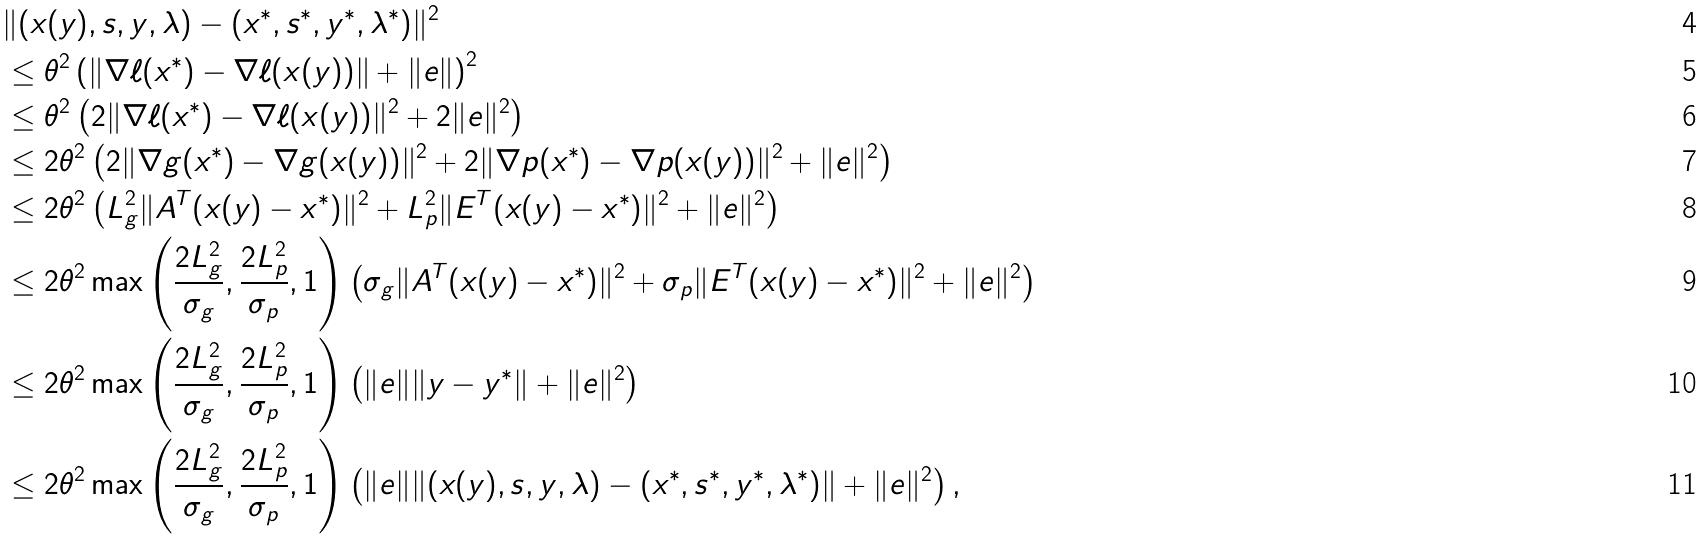Convert formula to latex. <formula><loc_0><loc_0><loc_500><loc_500>& \| ( x ( y ) , s , y , \lambda ) - ( x ^ { * } , s ^ { * } , y ^ { * } , \lambda ^ { * } ) \| ^ { 2 } \\ & \leq \theta ^ { 2 } \left ( \| \nabla \ell ( x ^ { * } ) - \nabla \ell ( x ( y ) ) \| + \| e \| \right ) ^ { 2 } \\ & \leq \theta ^ { 2 } \left ( 2 \| \nabla \ell ( x ^ { * } ) - \nabla \ell ( x ( y ) ) \| ^ { 2 } + 2 \| e \| ^ { 2 } \right ) \\ & \leq 2 \theta ^ { 2 } \left ( 2 \| \nabla g ( x ^ { * } ) - \nabla g ( x ( y ) ) \| ^ { 2 } + 2 \| \nabla p ( x ^ { * } ) - \nabla p ( x ( y ) ) \| ^ { 2 } + \| e \| ^ { 2 } \right ) \\ & \leq 2 \theta ^ { 2 } \left ( L ^ { 2 } _ { g } \| A ^ { T } ( x ( y ) - x ^ { * } ) \| ^ { 2 } + L ^ { 2 } _ { p } \| E ^ { T } ( x ( y ) - x ^ { * } ) \| ^ { 2 } + \| e \| ^ { 2 } \right ) \\ & \leq 2 \theta ^ { 2 } \max \left ( \frac { 2 L ^ { 2 } _ { g } } { \sigma _ { g } } , \frac { 2 L ^ { 2 } _ { p } } { \sigma _ { p } } , 1 \right ) \left ( \sigma _ { g } \| A ^ { T } ( x ( y ) - x ^ { * } ) \| ^ { 2 } + \sigma _ { p } \| E ^ { T } ( x ( y ) - x ^ { * } ) \| ^ { 2 } + \| e \| ^ { 2 } \right ) \\ & \leq 2 \theta ^ { 2 } \max \left ( \frac { 2 L ^ { 2 } _ { g } } { \sigma _ { g } } , \frac { 2 L ^ { 2 } _ { p } } { \sigma _ { p } } , 1 \right ) \left ( \| e \| \| y - y ^ { * } \| + \| e \| ^ { 2 } \right ) \\ & \leq 2 \theta ^ { 2 } \max \left ( \frac { 2 L ^ { 2 } _ { g } } { \sigma _ { g } } , \frac { 2 L ^ { 2 } _ { p } } { \sigma _ { p } } , 1 \right ) \left ( \| e \| \| ( x ( y ) , s , y , \lambda ) - ( x ^ { * } , s ^ { * } , y ^ { * } , \lambda ^ { * } ) \| + \| e \| ^ { 2 } \right ) ,</formula> 